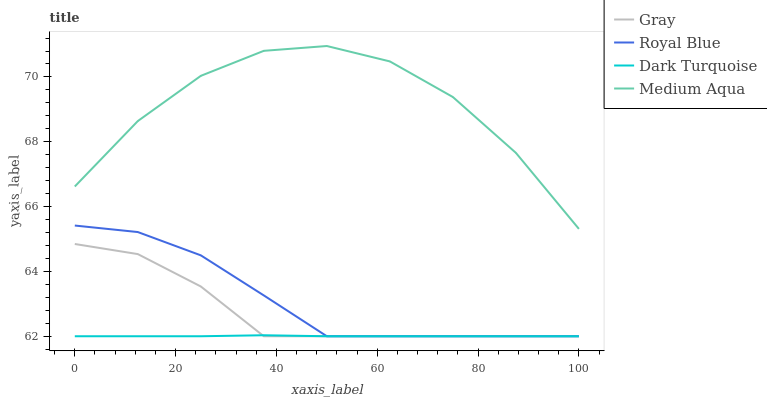Does Dark Turquoise have the minimum area under the curve?
Answer yes or no. Yes. Does Medium Aqua have the maximum area under the curve?
Answer yes or no. Yes. Does Medium Aqua have the minimum area under the curve?
Answer yes or no. No. Does Dark Turquoise have the maximum area under the curve?
Answer yes or no. No. Is Dark Turquoise the smoothest?
Answer yes or no. Yes. Is Medium Aqua the roughest?
Answer yes or no. Yes. Is Medium Aqua the smoothest?
Answer yes or no. No. Is Dark Turquoise the roughest?
Answer yes or no. No. Does Gray have the lowest value?
Answer yes or no. Yes. Does Medium Aqua have the lowest value?
Answer yes or no. No. Does Medium Aqua have the highest value?
Answer yes or no. Yes. Does Dark Turquoise have the highest value?
Answer yes or no. No. Is Dark Turquoise less than Medium Aqua?
Answer yes or no. Yes. Is Medium Aqua greater than Royal Blue?
Answer yes or no. Yes. Does Gray intersect Dark Turquoise?
Answer yes or no. Yes. Is Gray less than Dark Turquoise?
Answer yes or no. No. Is Gray greater than Dark Turquoise?
Answer yes or no. No. Does Dark Turquoise intersect Medium Aqua?
Answer yes or no. No. 